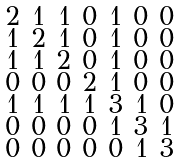Convert formula to latex. <formula><loc_0><loc_0><loc_500><loc_500>\begin{smallmatrix} 2 & 1 & 1 & 0 & 1 & 0 & 0 \\ 1 & 2 & 1 & 0 & 1 & 0 & 0 \\ 1 & 1 & 2 & 0 & 1 & 0 & 0 \\ 0 & 0 & 0 & 2 & 1 & 0 & 0 \\ 1 & 1 & 1 & 1 & 3 & 1 & 0 \\ 0 & 0 & 0 & 0 & 1 & 3 & 1 \\ 0 & 0 & 0 & 0 & 0 & 1 & 3 \end{smallmatrix}</formula> 